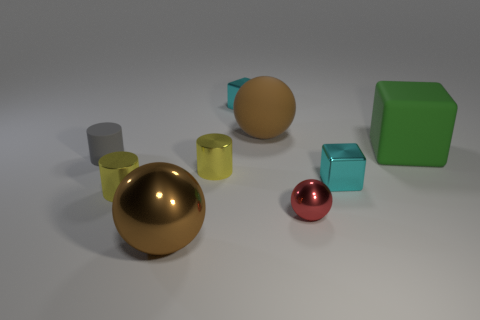Subtract all brown blocks. Subtract all cyan cylinders. How many blocks are left? 3 Subtract all cylinders. How many objects are left? 6 Subtract 0 purple cylinders. How many objects are left? 9 Subtract all red metal things. Subtract all tiny matte objects. How many objects are left? 7 Add 6 matte cylinders. How many matte cylinders are left? 7 Add 5 brown balls. How many brown balls exist? 7 